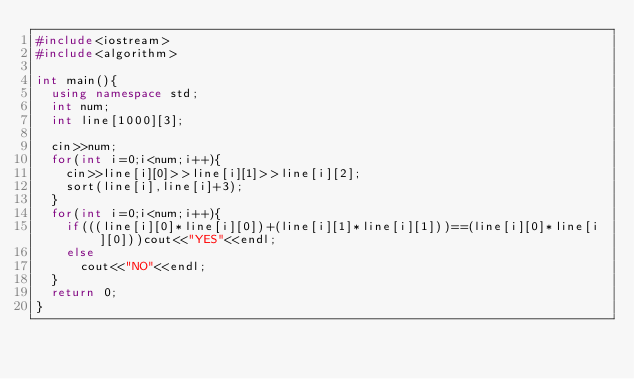<code> <loc_0><loc_0><loc_500><loc_500><_C++_>#include<iostream>
#include<algorithm>

int main(){
  using namespace std;
  int num;
  int line[1000][3];

  cin>>num;
  for(int i=0;i<num;i++){
    cin>>line[i][0]>>line[i][1]>>line[i][2];
    sort(line[i],line[i]+3);
  }
  for(int i=0;i<num;i++){
    if(((line[i][0]*line[i][0])+(line[i][1]*line[i][1]))==(line[i][0]*line[i][0]))cout<<"YES"<<endl;
    else
      cout<<"NO"<<endl;
  }
  return 0;
}</code> 